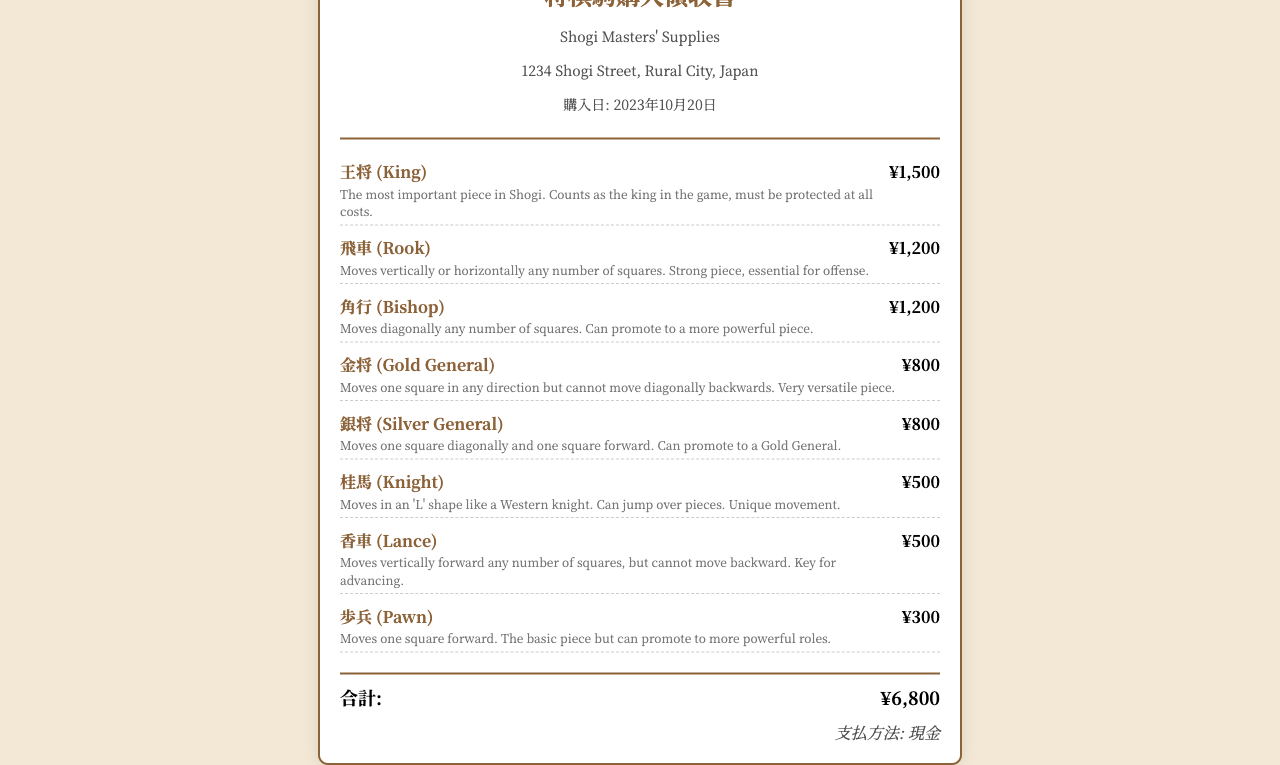何が購入されたか？ The receipt lists various Shogi pieces that were purchased.
Answer: 将棋駒 合計金額はいくらですか？ The total amount is specifically mentioned at the bottom of the receipt.
Answer: ¥6,800 キングの価格はいくらですか？ The price of the King piece is stated next to its name.
Answer: ¥1,500 購入日はいつですか？ The purchase date is noted in the store information section of the receipt.
Answer: 2023年10月20日 どのような支払方法が使用されましたか？ The payment method is indicated at the bottom of the receipt.
Answer: 現金 香車の説明は何ですか？ The description of the Lance piece is provided in the item section.
Answer: Moves vertically forward any number of squares, but cannot move backward. Key for advancing 銀将は何マス動けますか？ The movement ability of the Silver General piece can be found in its description.
Answer: 一マス diagonally and one square forward 購入したお店の名前は何ですか？ The store name is displayed prominently at the top of the receipt.
Answer: Shogi Masters' Supplies 